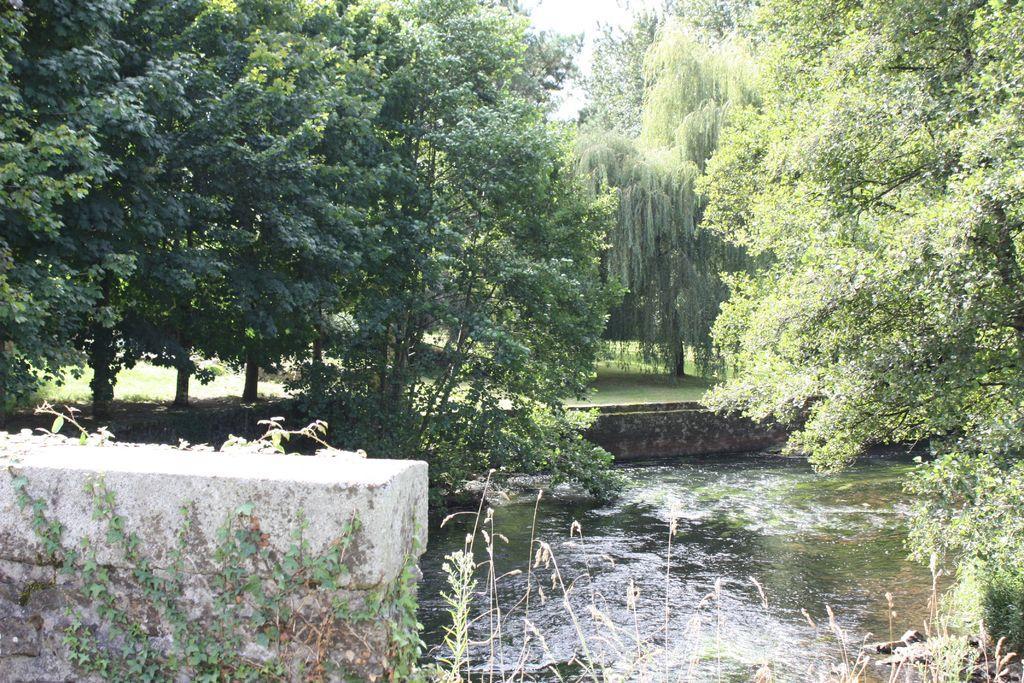Could you give a brief overview of what you see in this image? In this image, we can see water and there is a wall, we can see some green trees. 